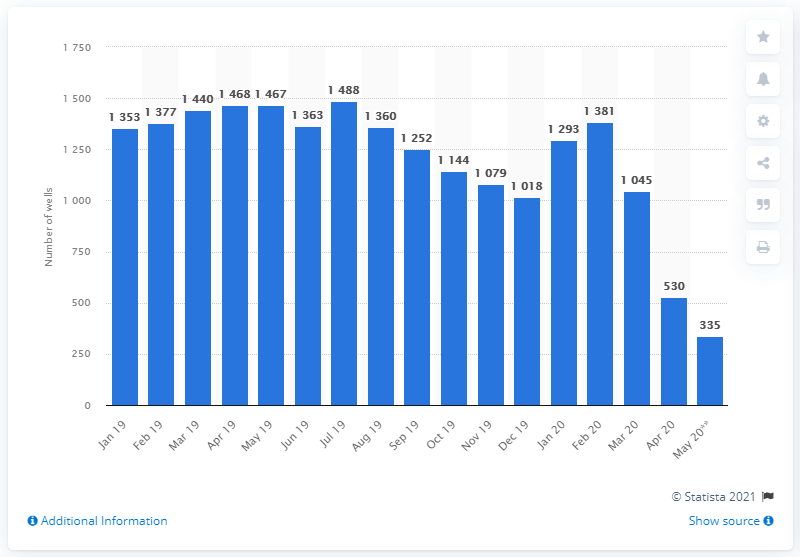Highlight a few significant elements in this photo. In May 2020, there were 335 hydraulic fracturing operations. 